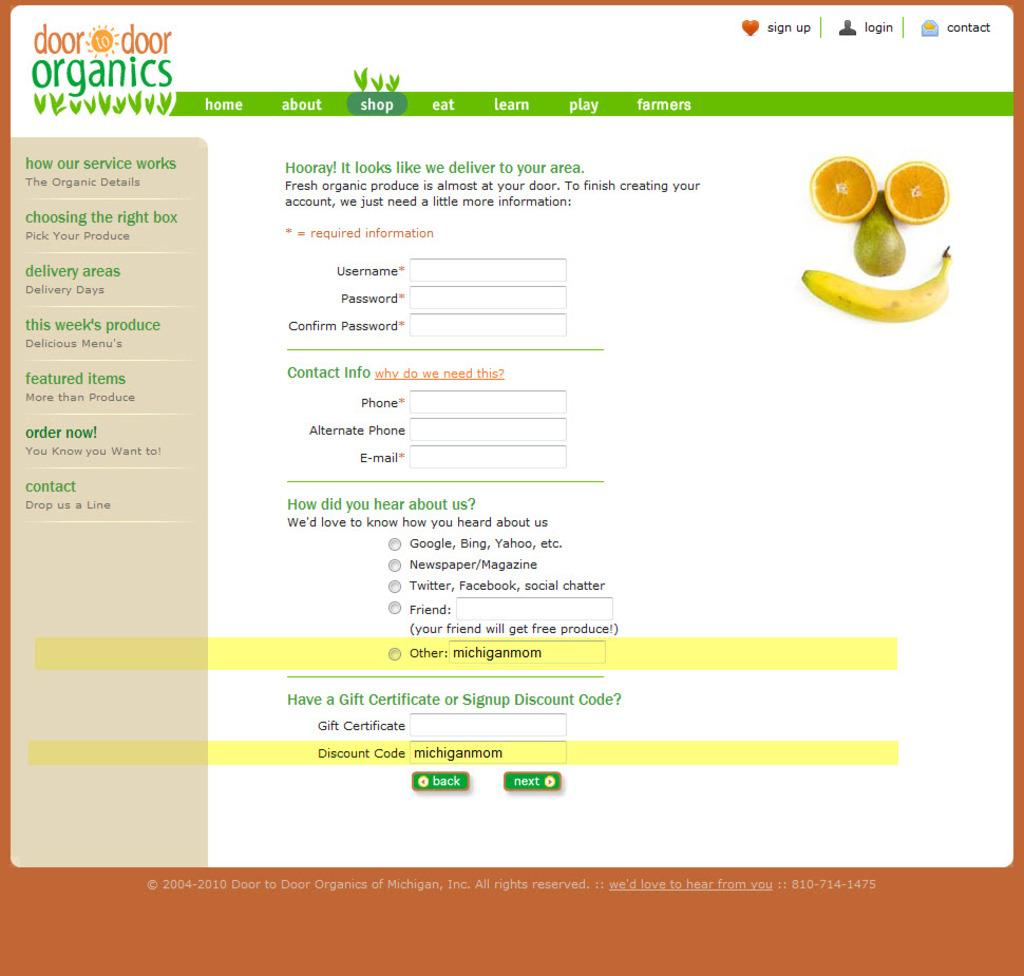What type of organization is represented by the image? The image is a web page of a food delivery organization. What services might this organization provide? This organization likely provides food delivery services to customers. What type of toothpaste is advertised on the web page? There is no toothpaste advertised on the web page, as it is a food delivery organization's web page. 